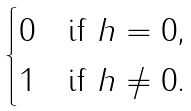<formula> <loc_0><loc_0><loc_500><loc_500>\begin{cases} 0 & \text {if $h=0$,} \\ 1 & \text {if $h\neq0$.} \end{cases}</formula> 